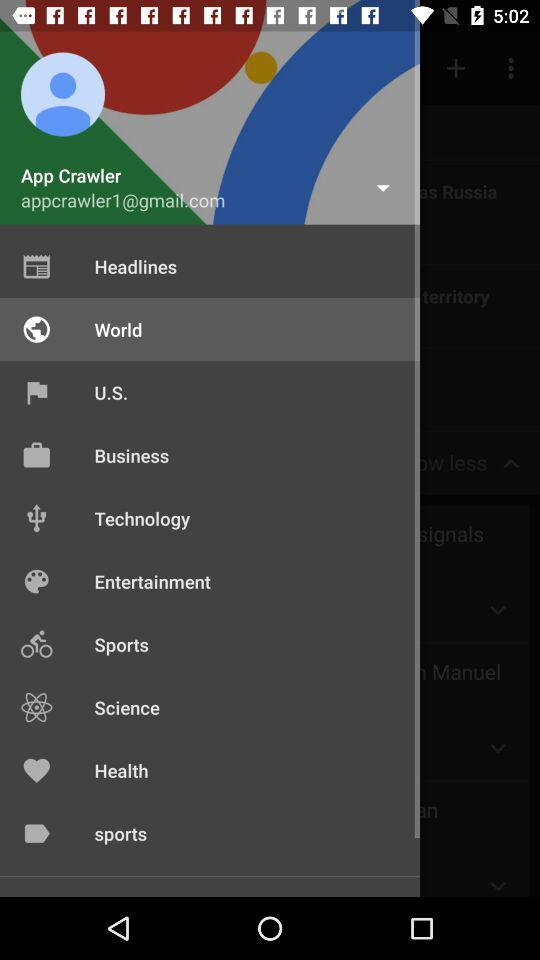What is email address? The email address is appcrawler1@gmail.com. 